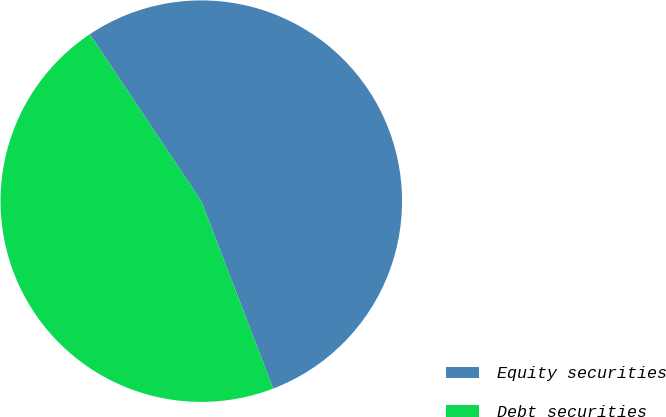Convert chart to OTSL. <chart><loc_0><loc_0><loc_500><loc_500><pie_chart><fcel>Equity securities<fcel>Debt securities<nl><fcel>53.54%<fcel>46.46%<nl></chart> 